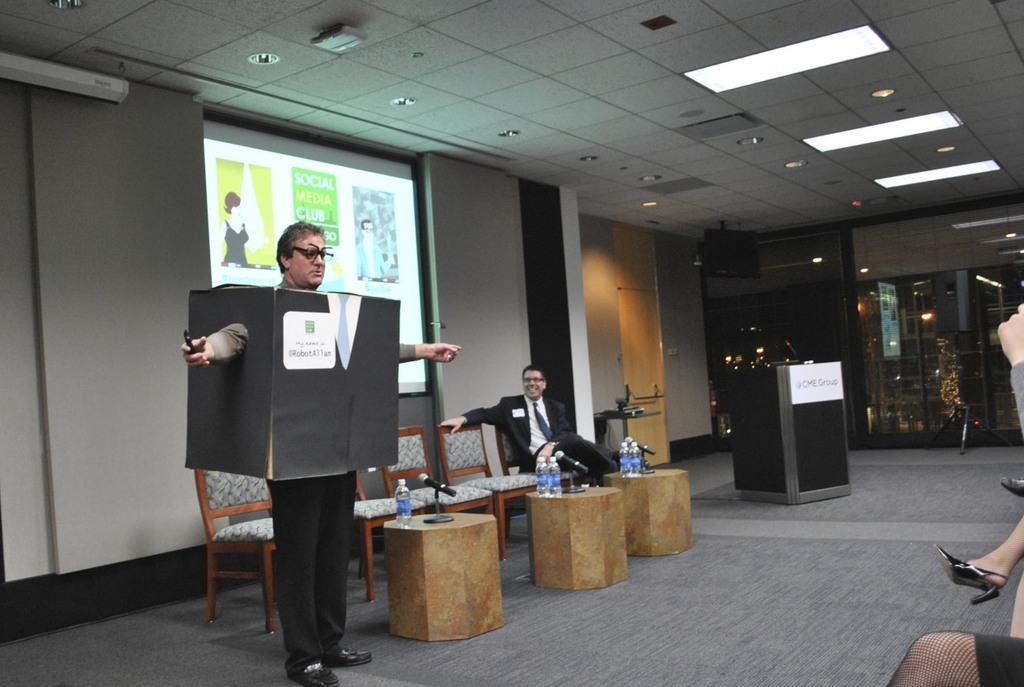Describe this image in one or two sentences. Here in this picture, in the front we can see a man wearing a box, standing over a place and beside him we can see number of chairs present and we can also see tables with microphones and bottles present over there and we can see another person sitting on a chair and smiling and beside him we can see a speech desk present and behind them we can see projector screen with something projected on it and we can see lights present on the roof and we can also see glass doors present and on the right side we can see other people sitting. 